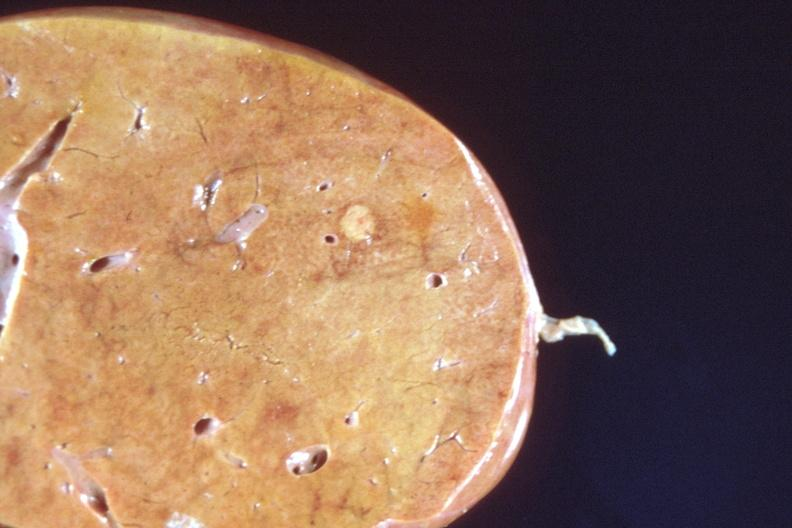s parathyroid present?
Answer the question using a single word or phrase. No 